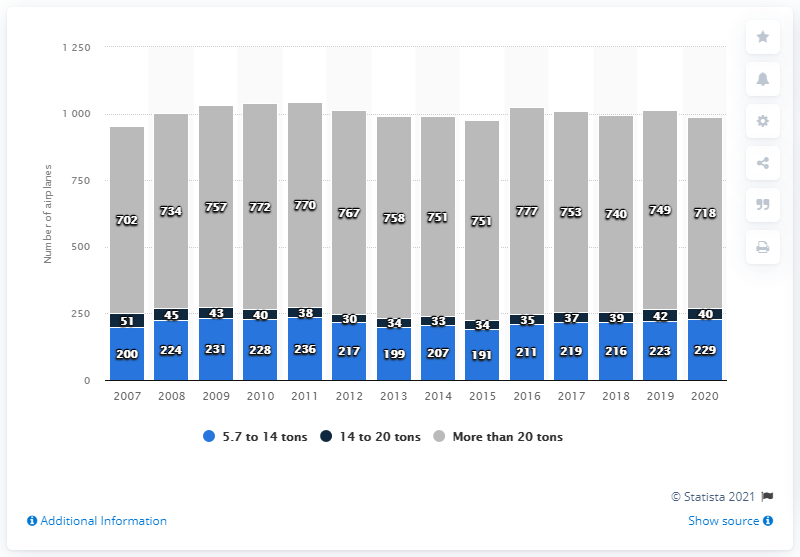Highlight a few significant elements in this photo. A total of 718 aircrafts with a take-off weight of more than 20 tons were recorded. The previous year's number of airplanes with a take-off weight exceeding 20 tons was 749. 